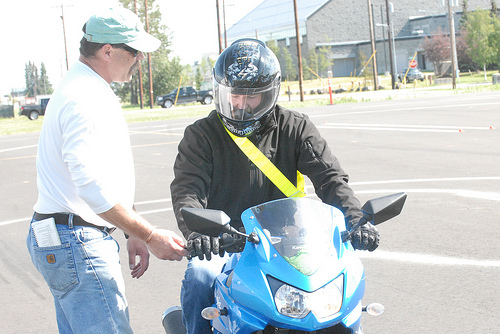<image>
Can you confirm if the man is on the motorcycle? Yes. Looking at the image, I can see the man is positioned on top of the motorcycle, with the motorcycle providing support. Is there a man to the left of the motorcycle? Yes. From this viewpoint, the man is positioned to the left side relative to the motorcycle. 